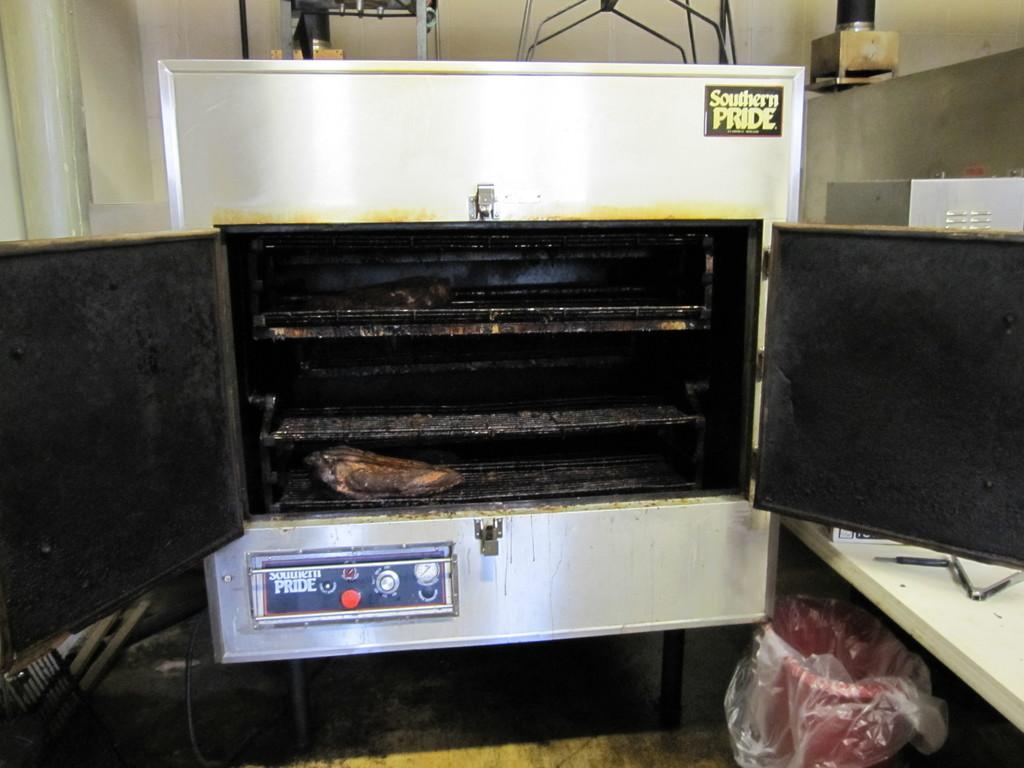<image>
Present a compact description of the photo's key features. an oven that has the term southern pride on it 